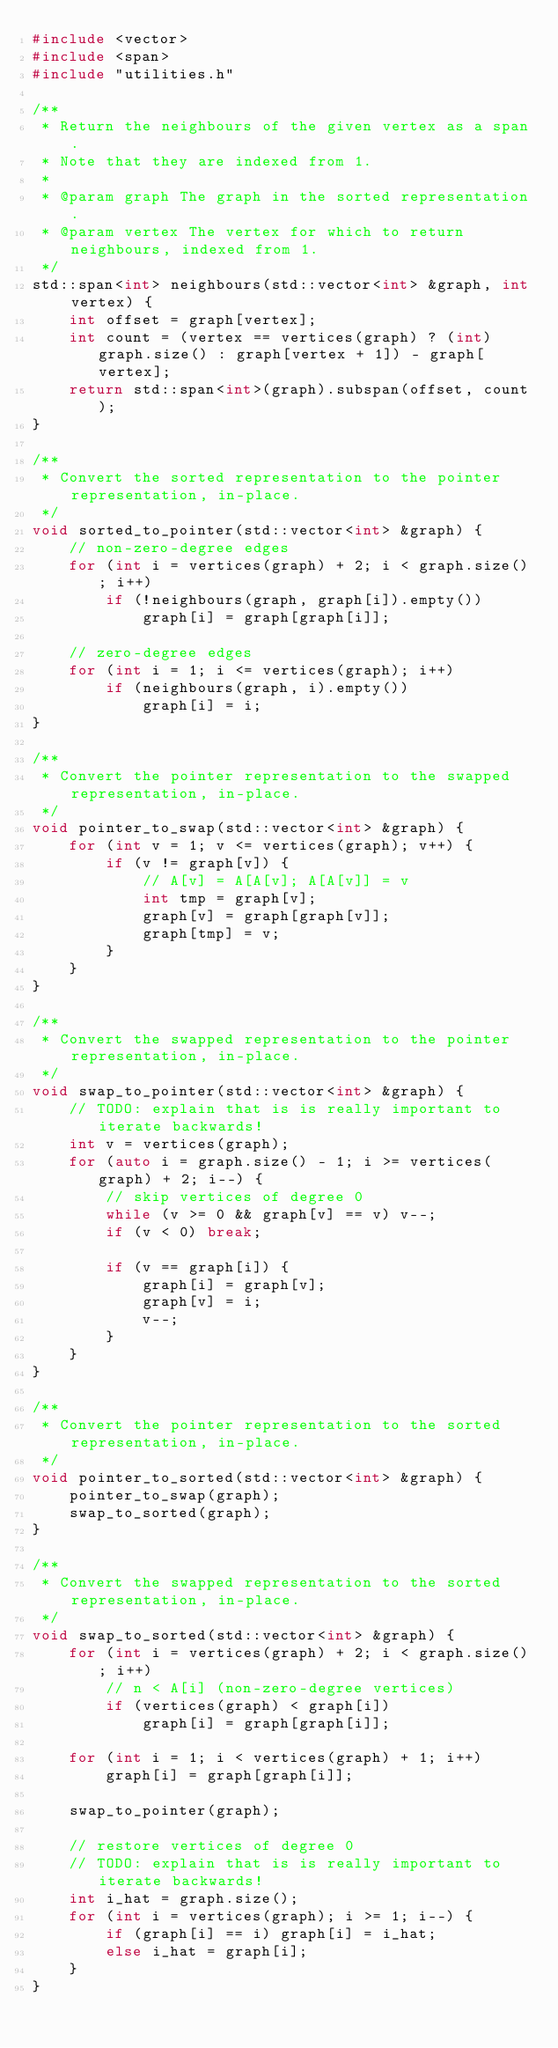Convert code to text. <code><loc_0><loc_0><loc_500><loc_500><_C++_>#include <vector>
#include <span>
#include "utilities.h"

/**
 * Return the neighbours of the given vertex as a span.
 * Note that they are indexed from 1.
 *
 * @param graph The graph in the sorted representation.
 * @param vertex The vertex for which to return neighbours, indexed from 1.
 */
std::span<int> neighbours(std::vector<int> &graph, int vertex) {
    int offset = graph[vertex];
    int count = (vertex == vertices(graph) ? (int) graph.size() : graph[vertex + 1]) - graph[vertex];
    return std::span<int>(graph).subspan(offset, count);
}

/**
 * Convert the sorted representation to the pointer representation, in-place.
 */
void sorted_to_pointer(std::vector<int> &graph) {
    // non-zero-degree edges
    for (int i = vertices(graph) + 2; i < graph.size(); i++)
        if (!neighbours(graph, graph[i]).empty())
            graph[i] = graph[graph[i]];

    // zero-degree edges
    for (int i = 1; i <= vertices(graph); i++)
        if (neighbours(graph, i).empty())
            graph[i] = i;
}

/**
 * Convert the pointer representation to the swapped representation, in-place.
 */
void pointer_to_swap(std::vector<int> &graph) {
    for (int v = 1; v <= vertices(graph); v++) {
        if (v != graph[v]) {
            // A[v] = A[A[v]; A[A[v]] = v
            int tmp = graph[v];
            graph[v] = graph[graph[v]];
            graph[tmp] = v;
        }
    }
}

/**
 * Convert the swapped representation to the pointer representation, in-place.
 */
void swap_to_pointer(std::vector<int> &graph) {
    // TODO: explain that is is really important to iterate backwards!
    int v = vertices(graph);
    for (auto i = graph.size() - 1; i >= vertices(graph) + 2; i--) {
        // skip vertices of degree 0
        while (v >= 0 && graph[v] == v) v--;
        if (v < 0) break;

        if (v == graph[i]) {
            graph[i] = graph[v];
            graph[v] = i;
            v--;
        }
    }
}

/**
 * Convert the pointer representation to the sorted representation, in-place.
 */
void pointer_to_sorted(std::vector<int> &graph) {
    pointer_to_swap(graph);
    swap_to_sorted(graph);
}

/**
 * Convert the swapped representation to the sorted representation, in-place.
 */
void swap_to_sorted(std::vector<int> &graph) {
    for (int i = vertices(graph) + 2; i < graph.size(); i++)
        // n < A[i] (non-zero-degree vertices)
        if (vertices(graph) < graph[i])
            graph[i] = graph[graph[i]];

    for (int i = 1; i < vertices(graph) + 1; i++)
        graph[i] = graph[graph[i]];

    swap_to_pointer(graph);

    // restore vertices of degree 0
    // TODO: explain that is is really important to iterate backwards!
    int i_hat = graph.size();
    for (int i = vertices(graph); i >= 1; i--) {
        if (graph[i] == i) graph[i] = i_hat;
        else i_hat = graph[i];
    }
}</code> 